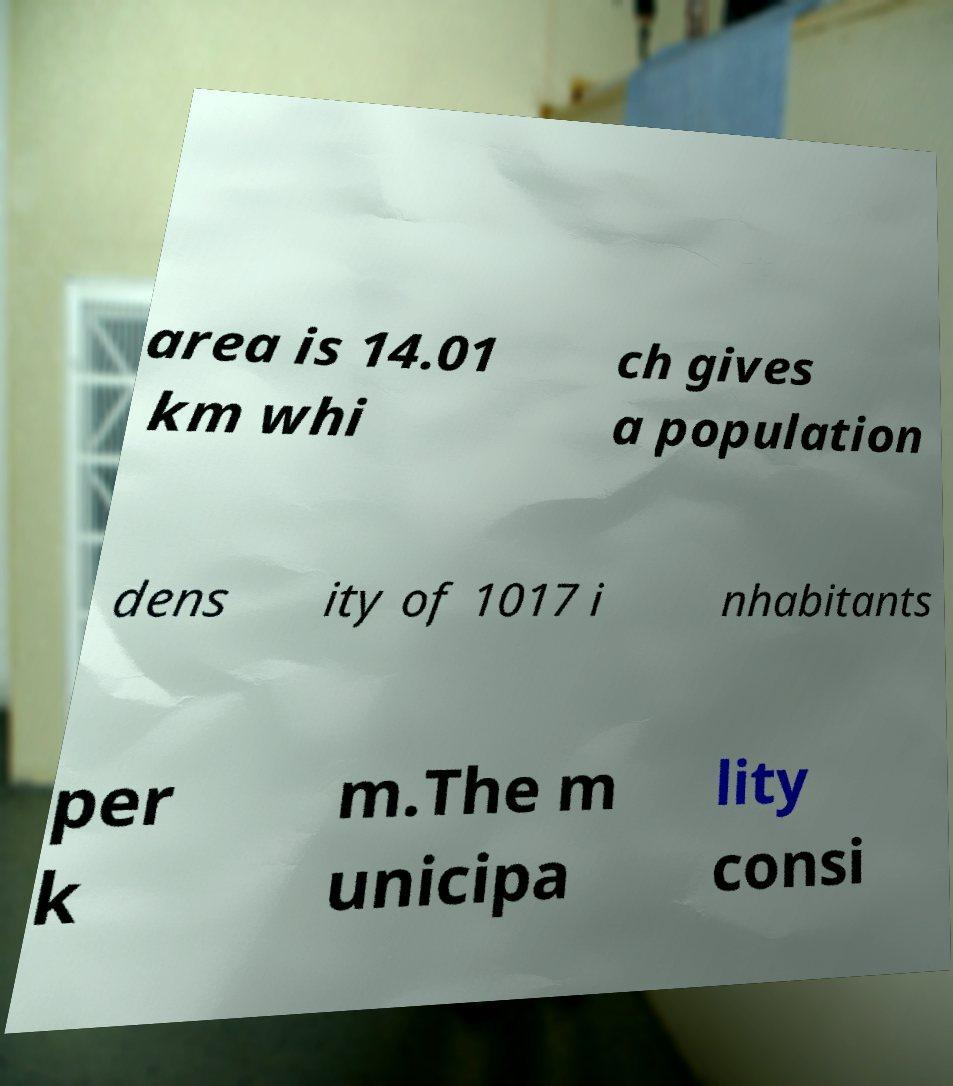There's text embedded in this image that I need extracted. Can you transcribe it verbatim? area is 14.01 km whi ch gives a population dens ity of 1017 i nhabitants per k m.The m unicipa lity consi 